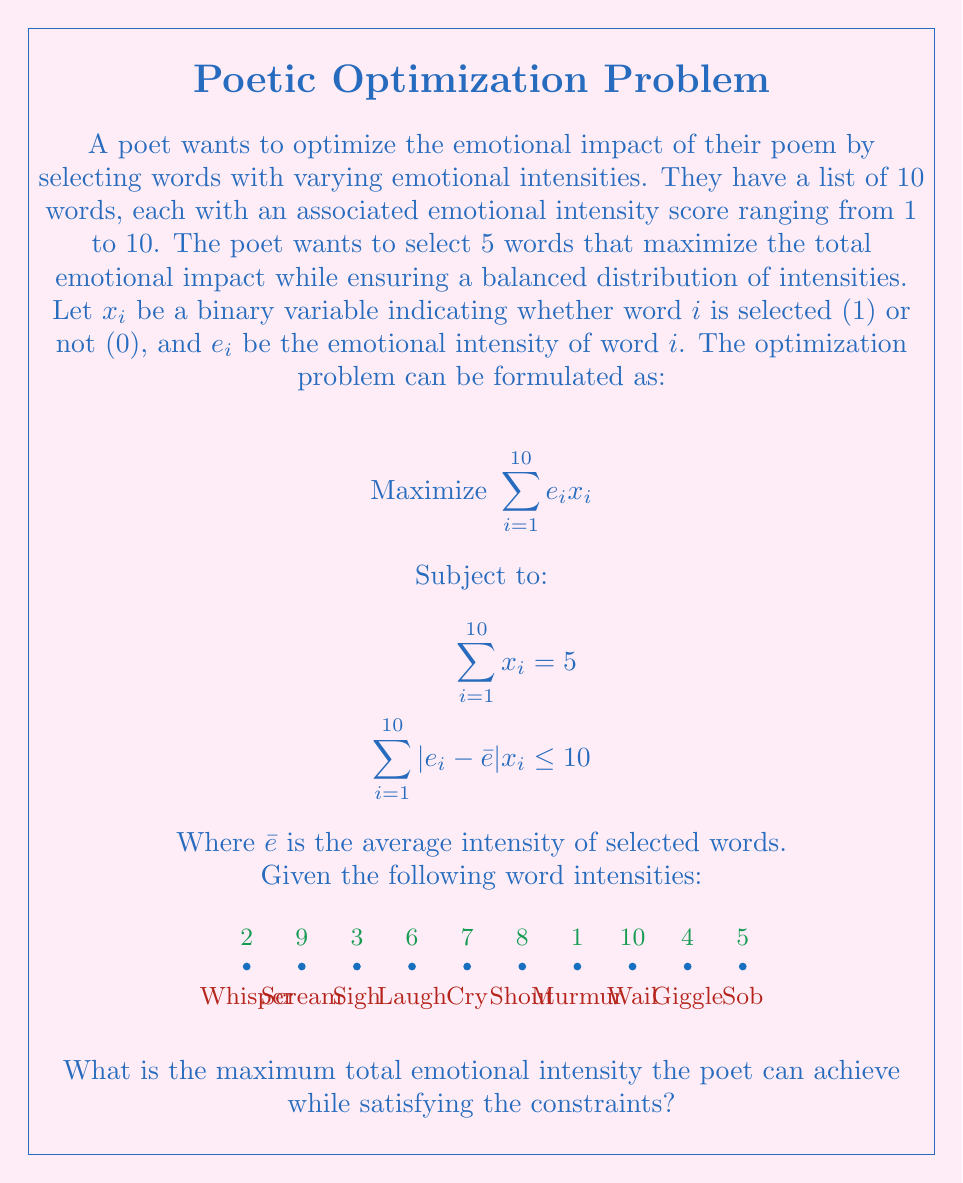Can you answer this question? To solve this optimization problem, we'll follow these steps:

1) First, we need to understand the constraints:
   - We must select exactly 5 words
   - The sum of the absolute differences between each selected word's intensity and the average intensity should not exceed 10

2) Let's start by selecting the 5 words with the highest intensities:
   Wail (10), Scream (9), Shout (8), Cry (7), Laugh (6)

3) Calculate the total intensity:
   $10 + 9 + 8 + 7 + 6 = 40$

4) Check if this selection satisfies the balance constraint:
   Average intensity: $\bar{e} = 40 / 5 = 8$
   Sum of absolute differences:
   $|10-8| + |9-8| + |8-8| + |7-8| + |6-8| = 2 + 1 + 0 + 1 + 2 = 6$

   This satisfies the constraint as $6 \leq 10$

5) Since this selection satisfies both constraints and uses the words with the highest intensities, it must be the optimal solution.

6) Therefore, the maximum total emotional intensity is 40.
Answer: 40 